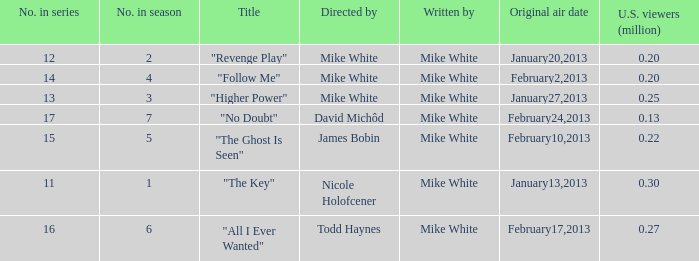What is the name of the episode directed by james bobin "The Ghost Is Seen". 